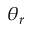Convert formula to latex. <formula><loc_0><loc_0><loc_500><loc_500>\theta _ { r }</formula> 